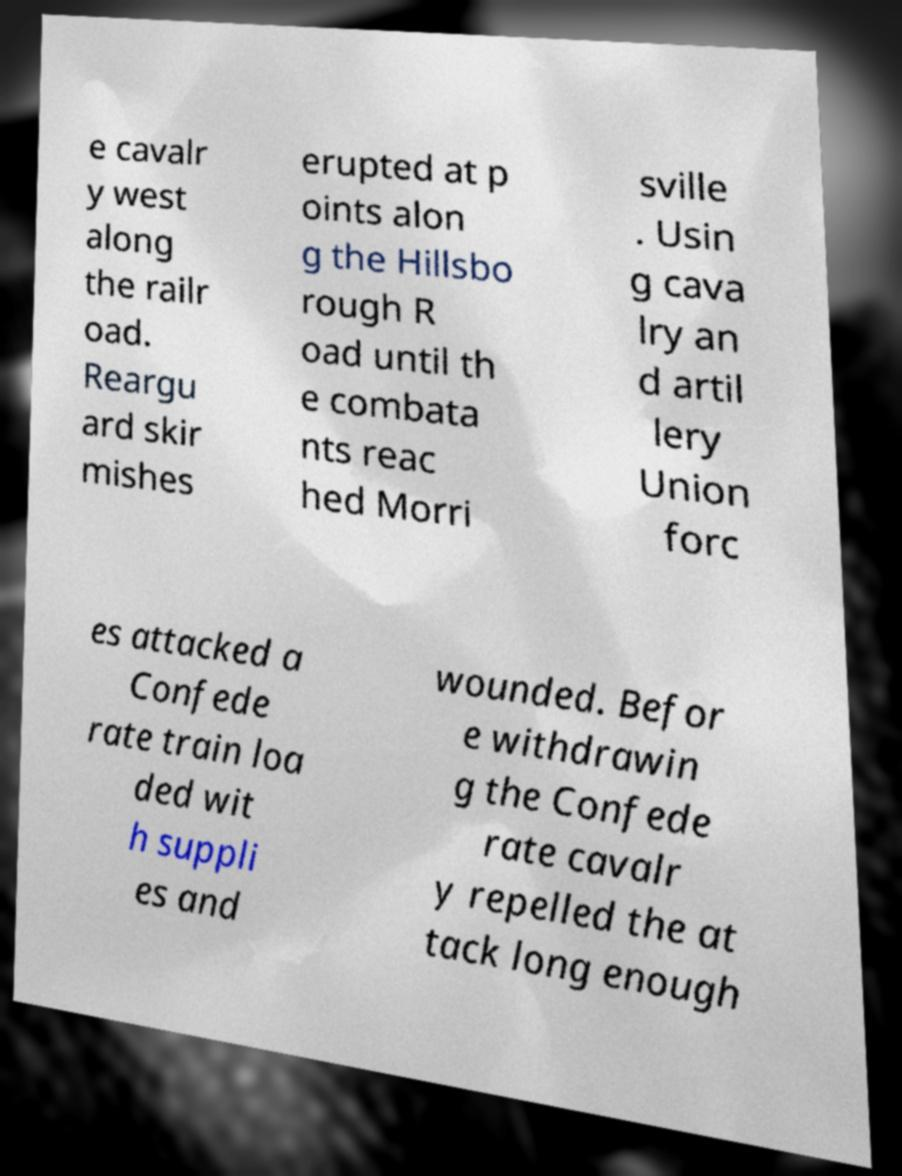What messages or text are displayed in this image? I need them in a readable, typed format. e cavalr y west along the railr oad. Reargu ard skir mishes erupted at p oints alon g the Hillsbo rough R oad until th e combata nts reac hed Morri sville . Usin g cava lry an d artil lery Union forc es attacked a Confede rate train loa ded wit h suppli es and wounded. Befor e withdrawin g the Confede rate cavalr y repelled the at tack long enough 